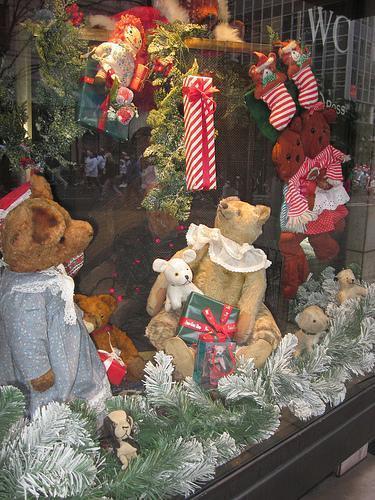How many stockings are there?
Give a very brief answer. 2. 